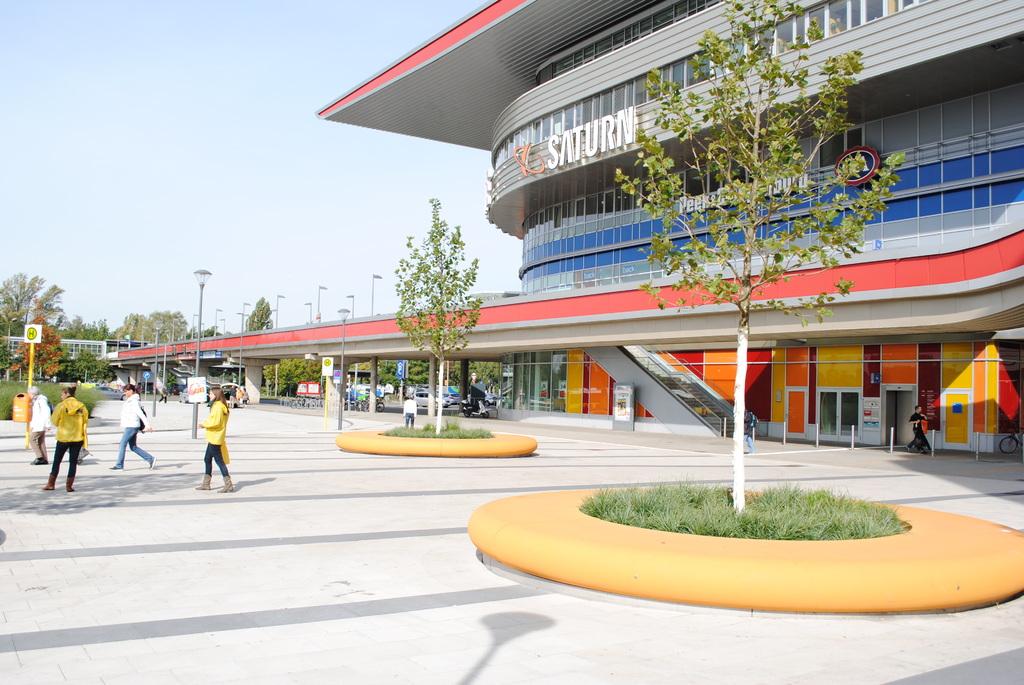What is the name of the school?
Provide a succinct answer. Saturn. 